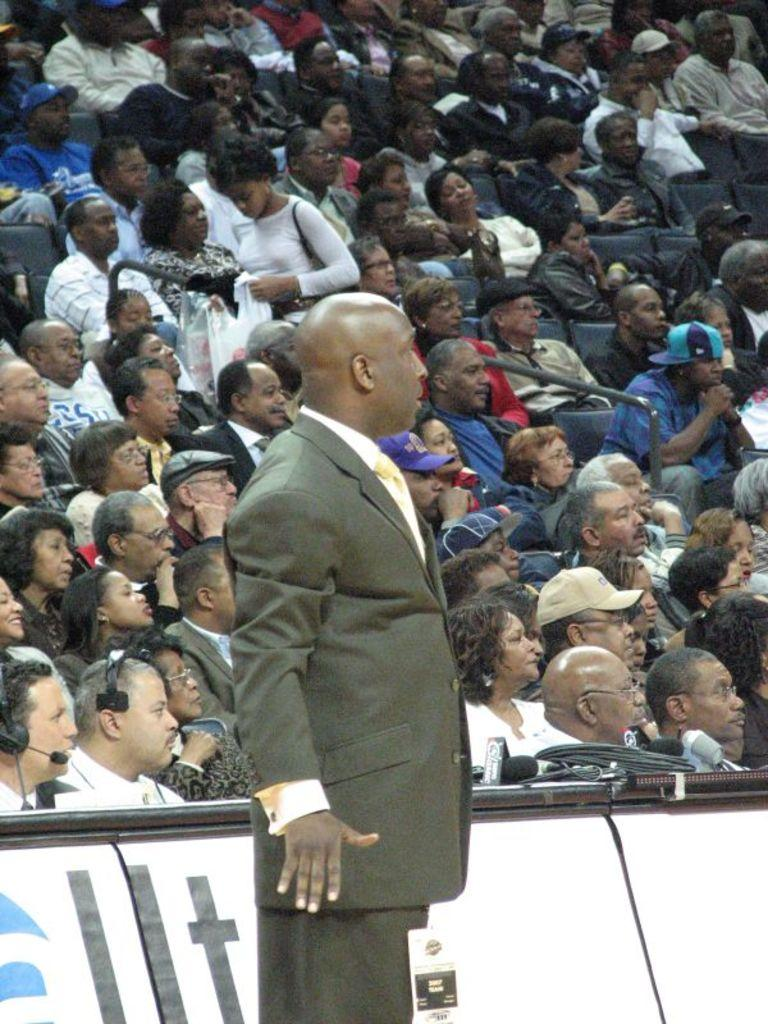What is the main subject of the image? There is a man standing in the image. What objects can be seen near the man? Microphones are present in the image. What else is visible in the image besides the man and microphones? There are objects on tables in the image. What can be seen in the background of the image? There is an audience in the background of the image. Can you tell me how many zephyrs are present in the image? There are no zephyrs present in the image, as a zephyr is a gentle breeze and not a physical object that can be seen. 